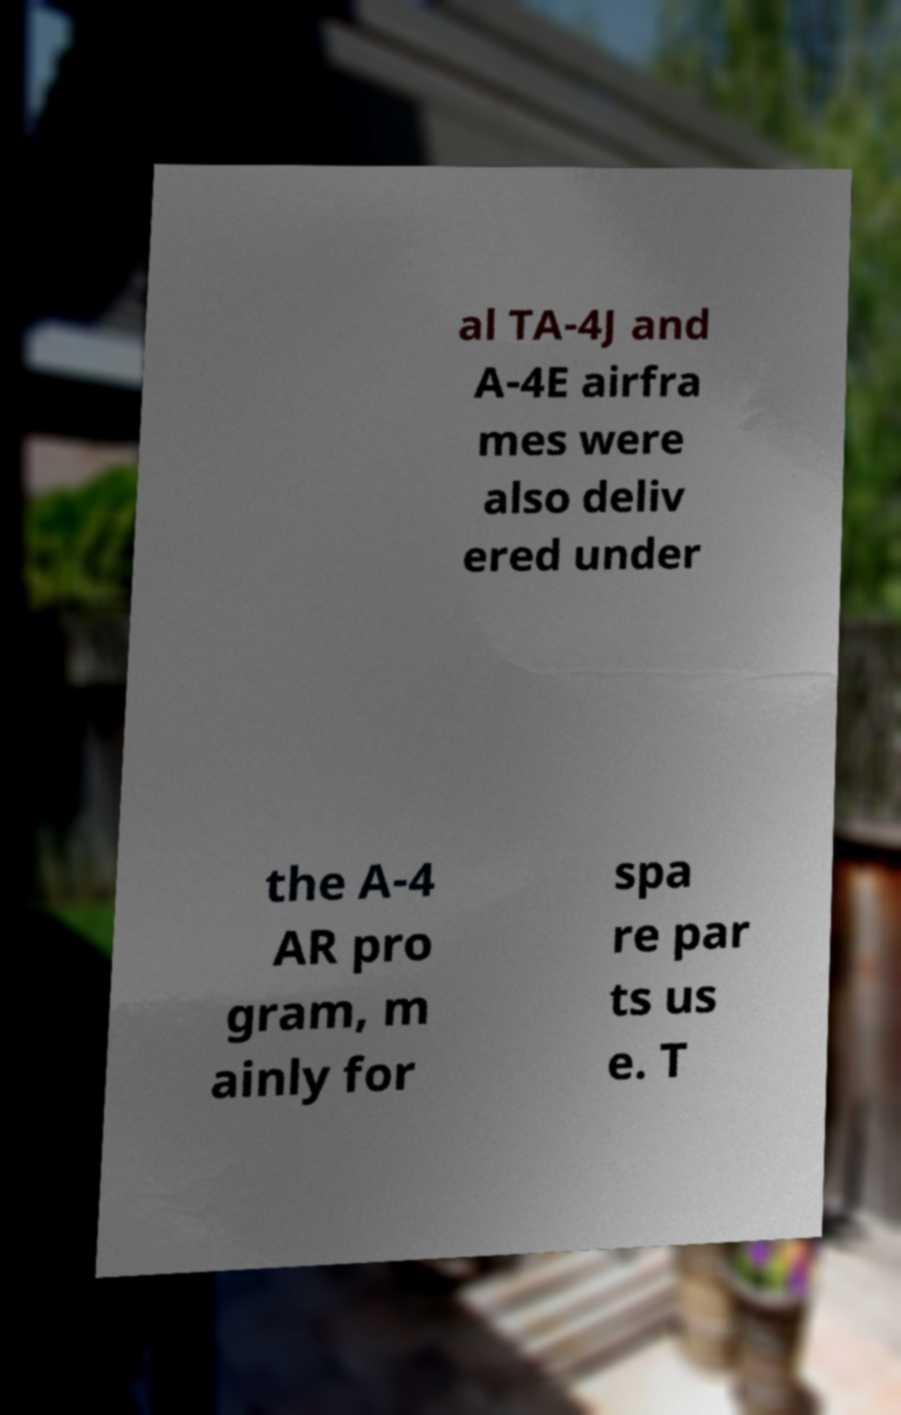Can you read and provide the text displayed in the image?This photo seems to have some interesting text. Can you extract and type it out for me? al TA-4J and A-4E airfra mes were also deliv ered under the A-4 AR pro gram, m ainly for spa re par ts us e. T 